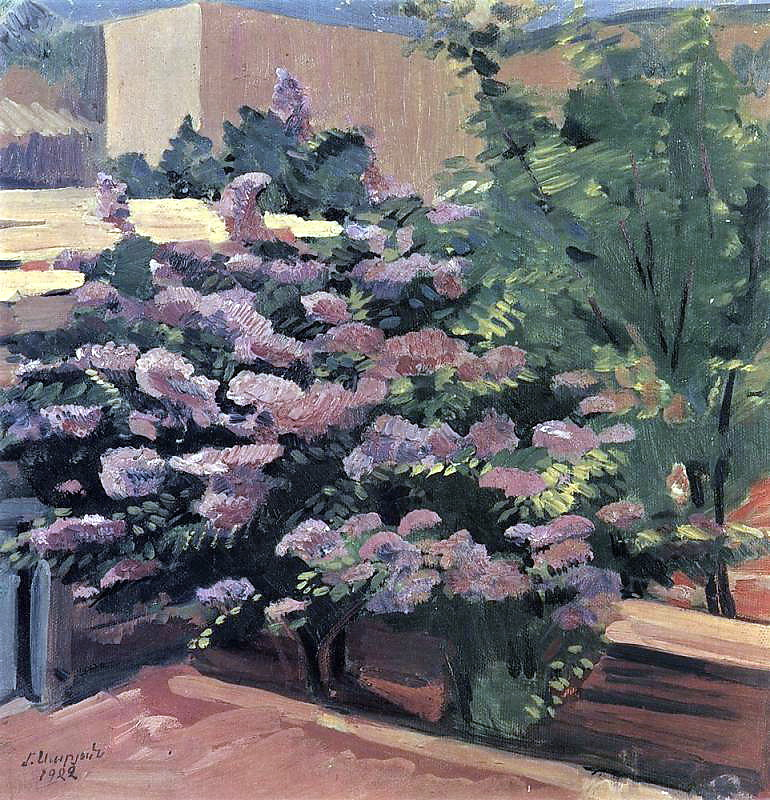If you were to step into this painting, what magical elements might you discover? Stepping into this painting, you might find that this garden is enchanted with magical elements. Every bloom could whisper sweet secrets when you brush past, and the leaves might shimmer with tiny, hidden fairies that appear only when the first light of dawn touches them. The garden's pathways could shift and change, leading you to new and secret nooks filled with ancient, mystical plants that glow softly in the twilight. Perhaps there is a wise old tree that speaks in a language of rustling leaves, offering wise advice and guidance to the garden's visitors. This magical garden would be a place of endless wonder and discovery, alive with the enchantments of nature and unseen magical forces. 